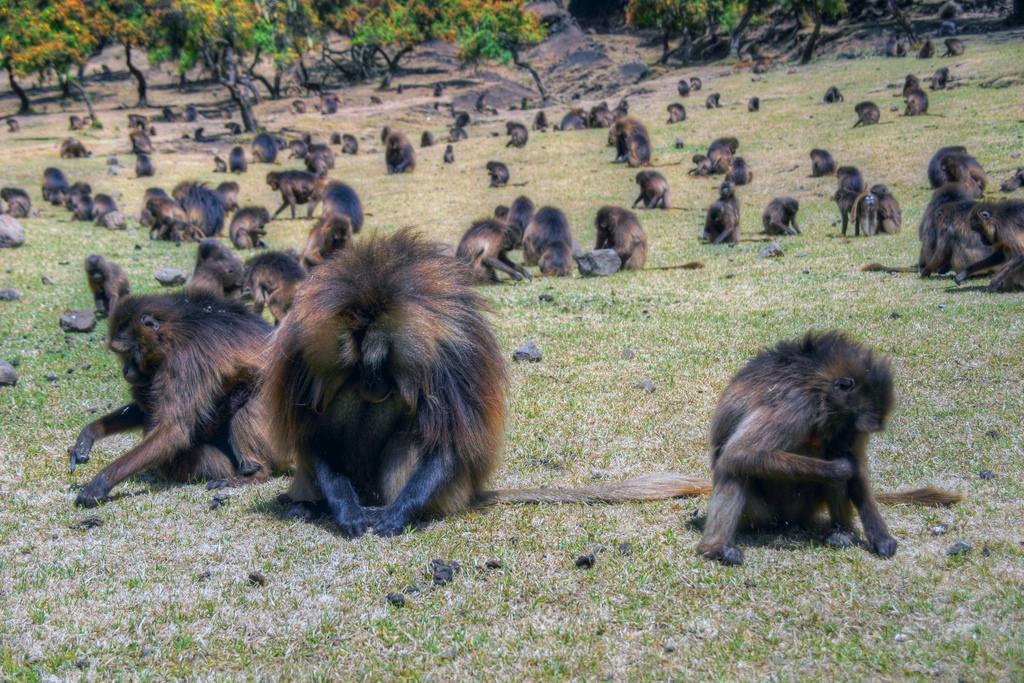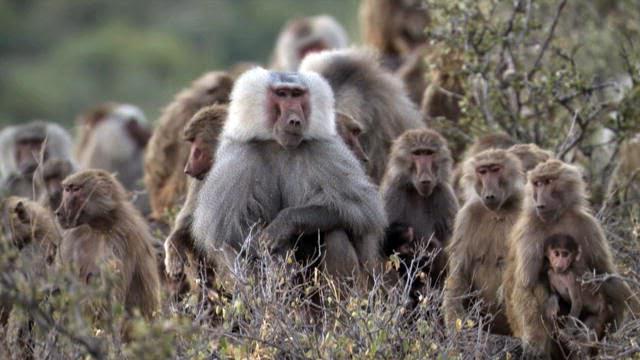The first image is the image on the left, the second image is the image on the right. For the images shown, is this caption "There are no more than 4 animals." true? Answer yes or no. No. The first image is the image on the left, the second image is the image on the right. For the images displayed, is the sentence "In one of the images there is a primate in close proximity to a large, wild cat." factually correct? Answer yes or no. No. The first image is the image on the left, the second image is the image on the right. Considering the images on both sides, is "There are exactly two animals in the image on the right." valid? Answer yes or no. No. The first image is the image on the left, the second image is the image on the right. Considering the images on both sides, is "There are no felines in the images." valid? Answer yes or no. Yes. 